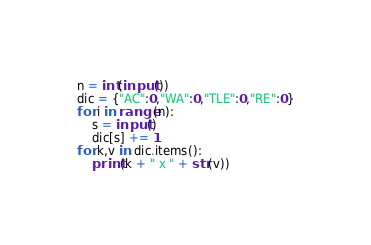<code> <loc_0><loc_0><loc_500><loc_500><_Python_>n = int(input())
dic = {"AC":0,"WA":0,"TLE":0,"RE":0}
for i in range(n):
    s = input()
    dic[s] += 1
for k,v in dic.items():
    print(k + " x " + str(v))</code> 